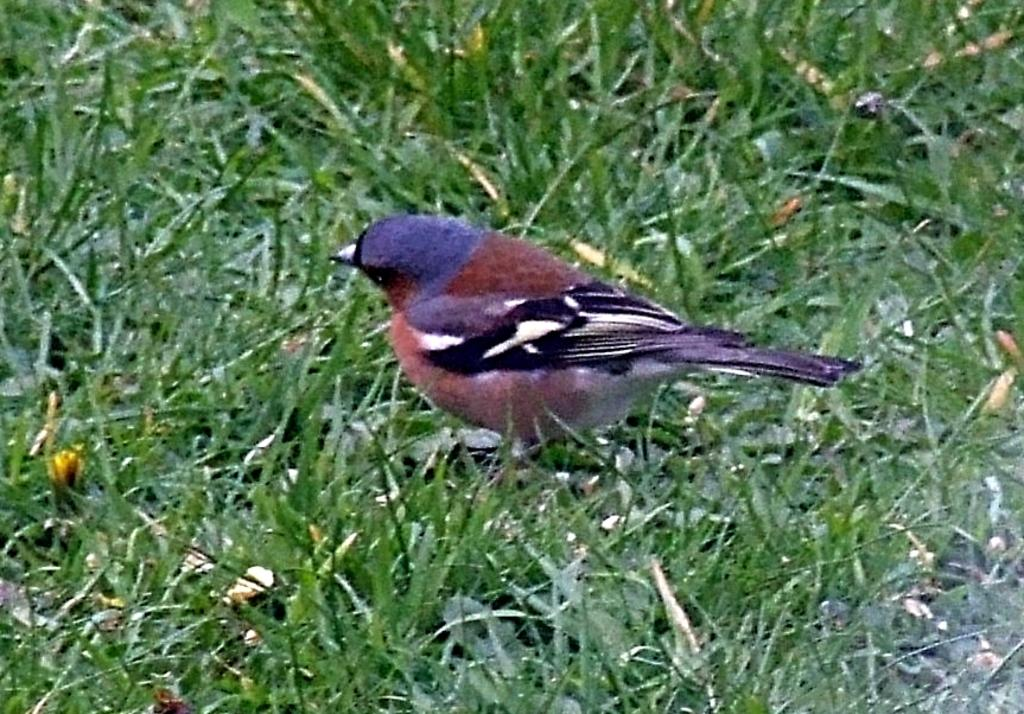What type of animal can be seen in the image? There is a bird in the image. What is the bird standing on? The bird is standing on the surface of grass. How many eggs are visible in the image? There are no eggs visible in the image; it only features a bird standing on grass. 